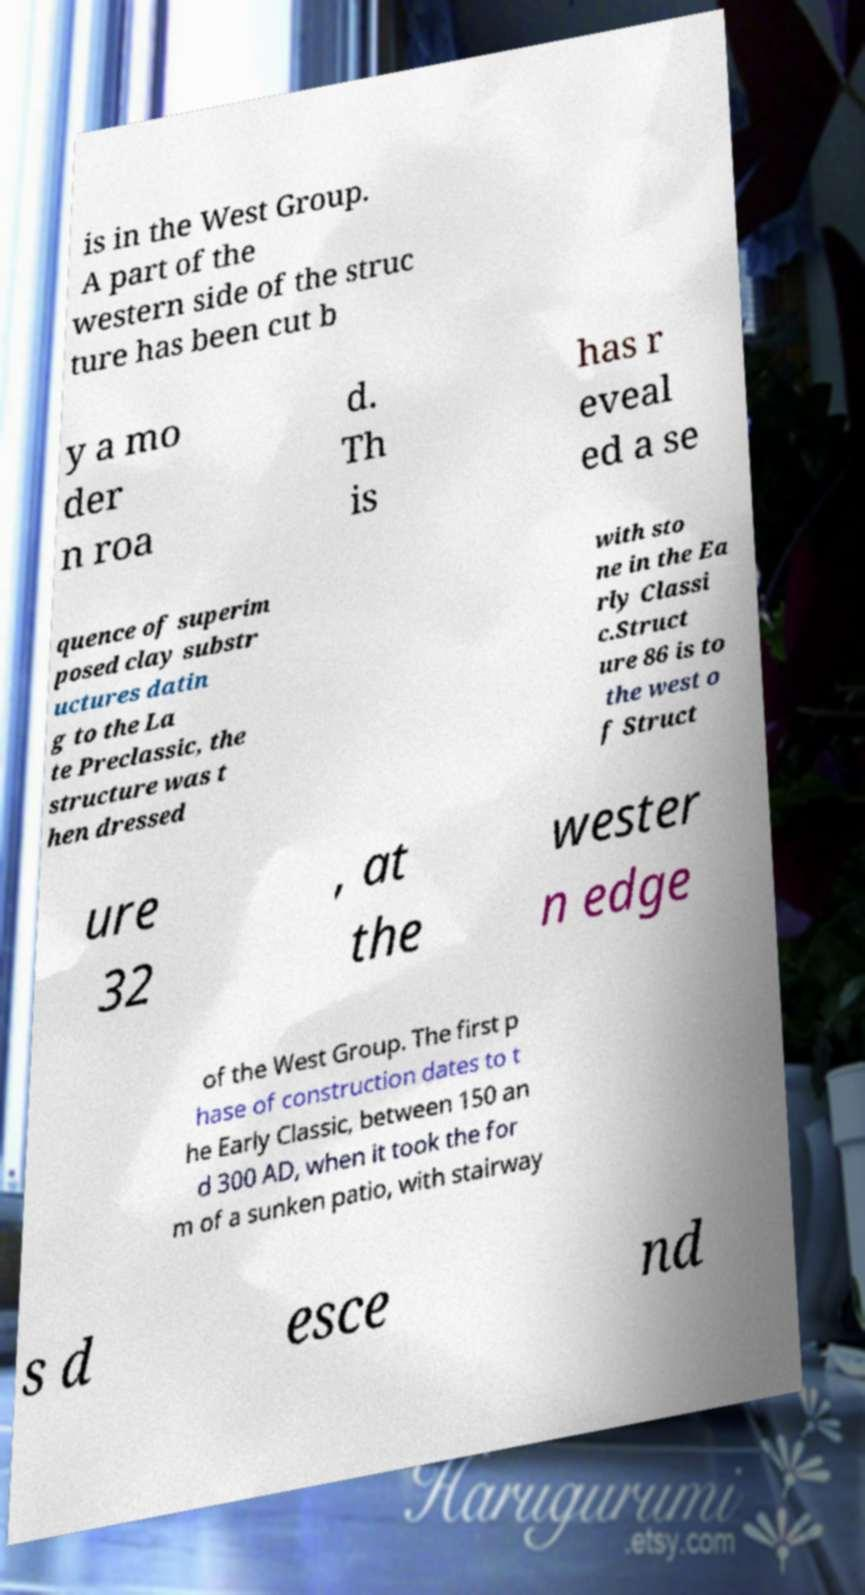Can you read and provide the text displayed in the image?This photo seems to have some interesting text. Can you extract and type it out for me? is in the West Group. A part of the western side of the struc ture has been cut b y a mo der n roa d. Th is has r eveal ed a se quence of superim posed clay substr uctures datin g to the La te Preclassic, the structure was t hen dressed with sto ne in the Ea rly Classi c.Struct ure 86 is to the west o f Struct ure 32 , at the wester n edge of the West Group. The first p hase of construction dates to t he Early Classic, between 150 an d 300 AD, when it took the for m of a sunken patio, with stairway s d esce nd 